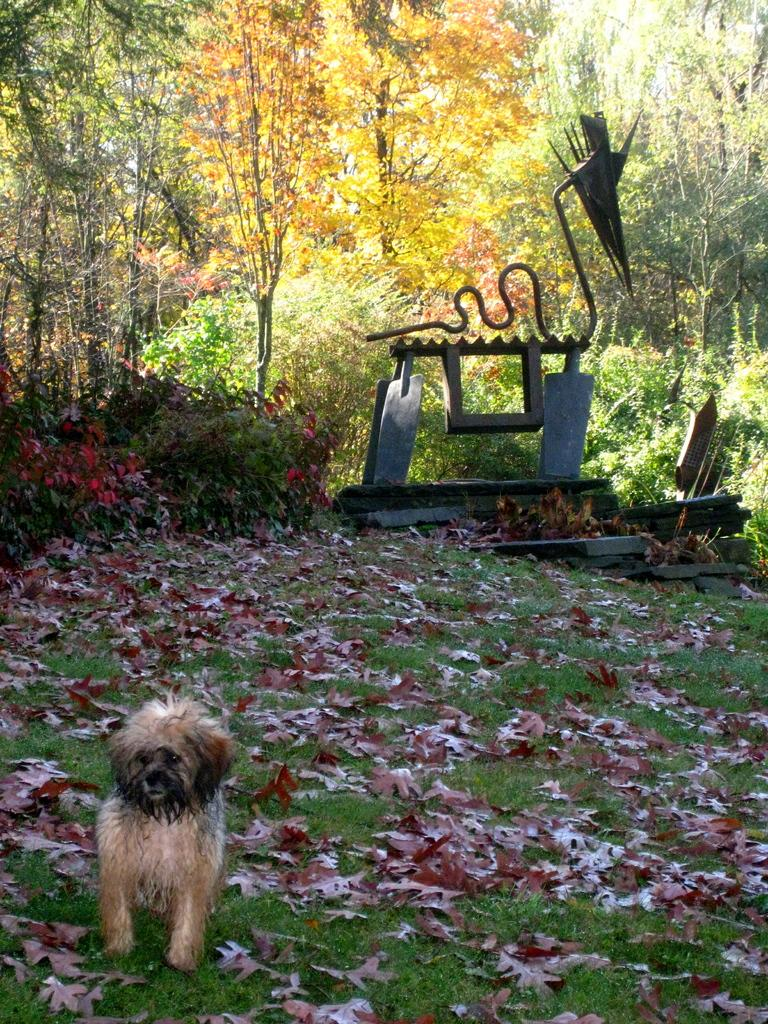What type of animal is in the image? There is a dog in the image. Where is the dog located in the image? The dog is at the bottom of the image. What can be seen in the background of the image? There are trees in the background of the image. What is on the right side of the image? There is an object on the right side of the image. What type of store can be seen on the edge of the image? There is no store present in the image; it features a dog at the bottom with trees in the background and an object on the right side. 